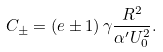Convert formula to latex. <formula><loc_0><loc_0><loc_500><loc_500>C _ { \pm } = \left ( e \pm 1 \right ) \gamma \frac { R ^ { 2 } } { \alpha ^ { \prime } U _ { 0 } ^ { 2 } } .</formula> 